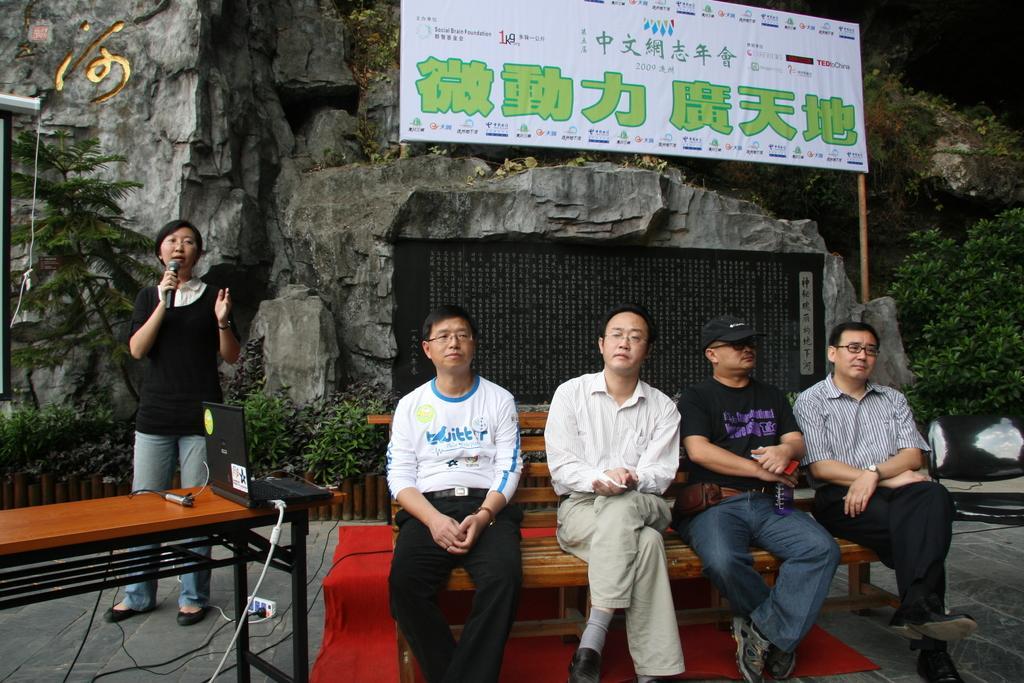Could you give a brief overview of what you see in this image? there are so many people sitting on a bench behind them there is a rock mountain and women speaking on the microphone. 